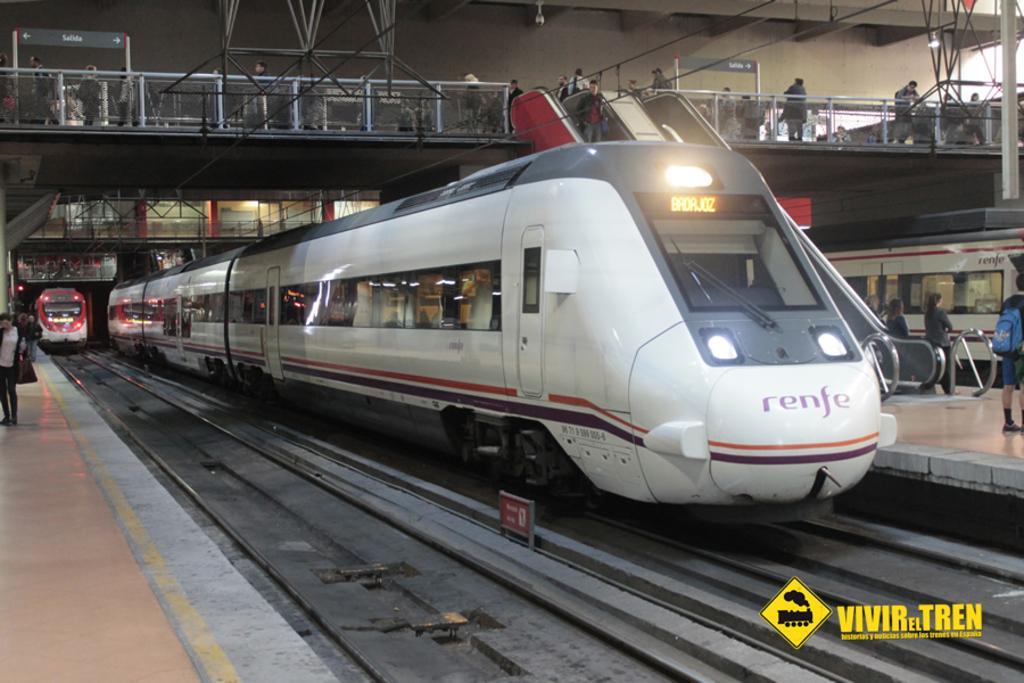How would you summarize this image in a sentence or two? In this picture we can see the railings, beams, poles, people, boards. We can see the trains, railway tracks, objects, platforms, escalators and the lights. At the bottom portion of the picture we can see watermark. 